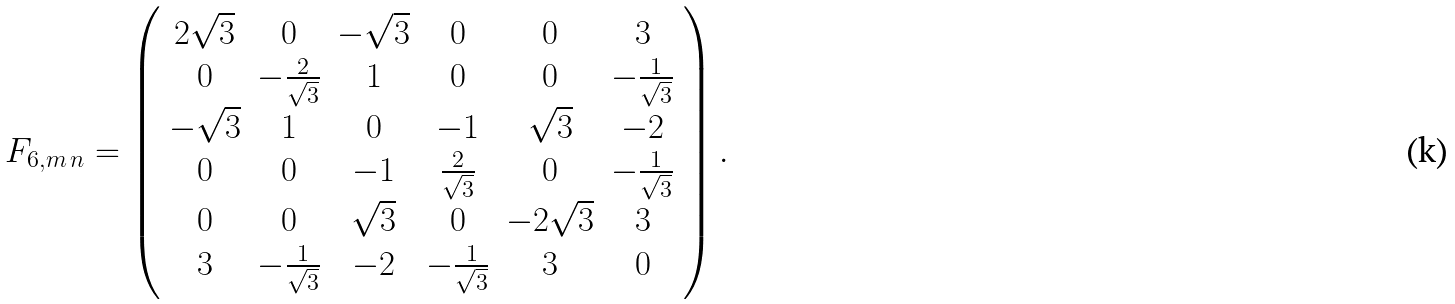Convert formula to latex. <formula><loc_0><loc_0><loc_500><loc_500>F _ { 6 , m \, n } = \left ( \begin{array} { c c c c c c } 2 \sqrt { 3 } & 0 & - \sqrt { 3 } & 0 & 0 & 3 \\ 0 & - \frac { 2 } { \sqrt { 3 } } & 1 & 0 & 0 & - \frac { 1 } { \sqrt { 3 } } \\ - \sqrt { 3 } & 1 & 0 & - 1 & \sqrt { 3 } & - 2 \\ 0 & 0 & - 1 & \frac { 2 } { \sqrt { 3 } } & 0 & - \frac { 1 } { \sqrt { 3 } } \\ 0 & 0 & \sqrt { 3 } & 0 & - 2 \sqrt { 3 } & 3 \\ 3 & - \frac { 1 } { \sqrt { 3 } } & - 2 & - \frac { 1 } { \sqrt { 3 } } & 3 & 0 \end{array} \right ) .</formula> 